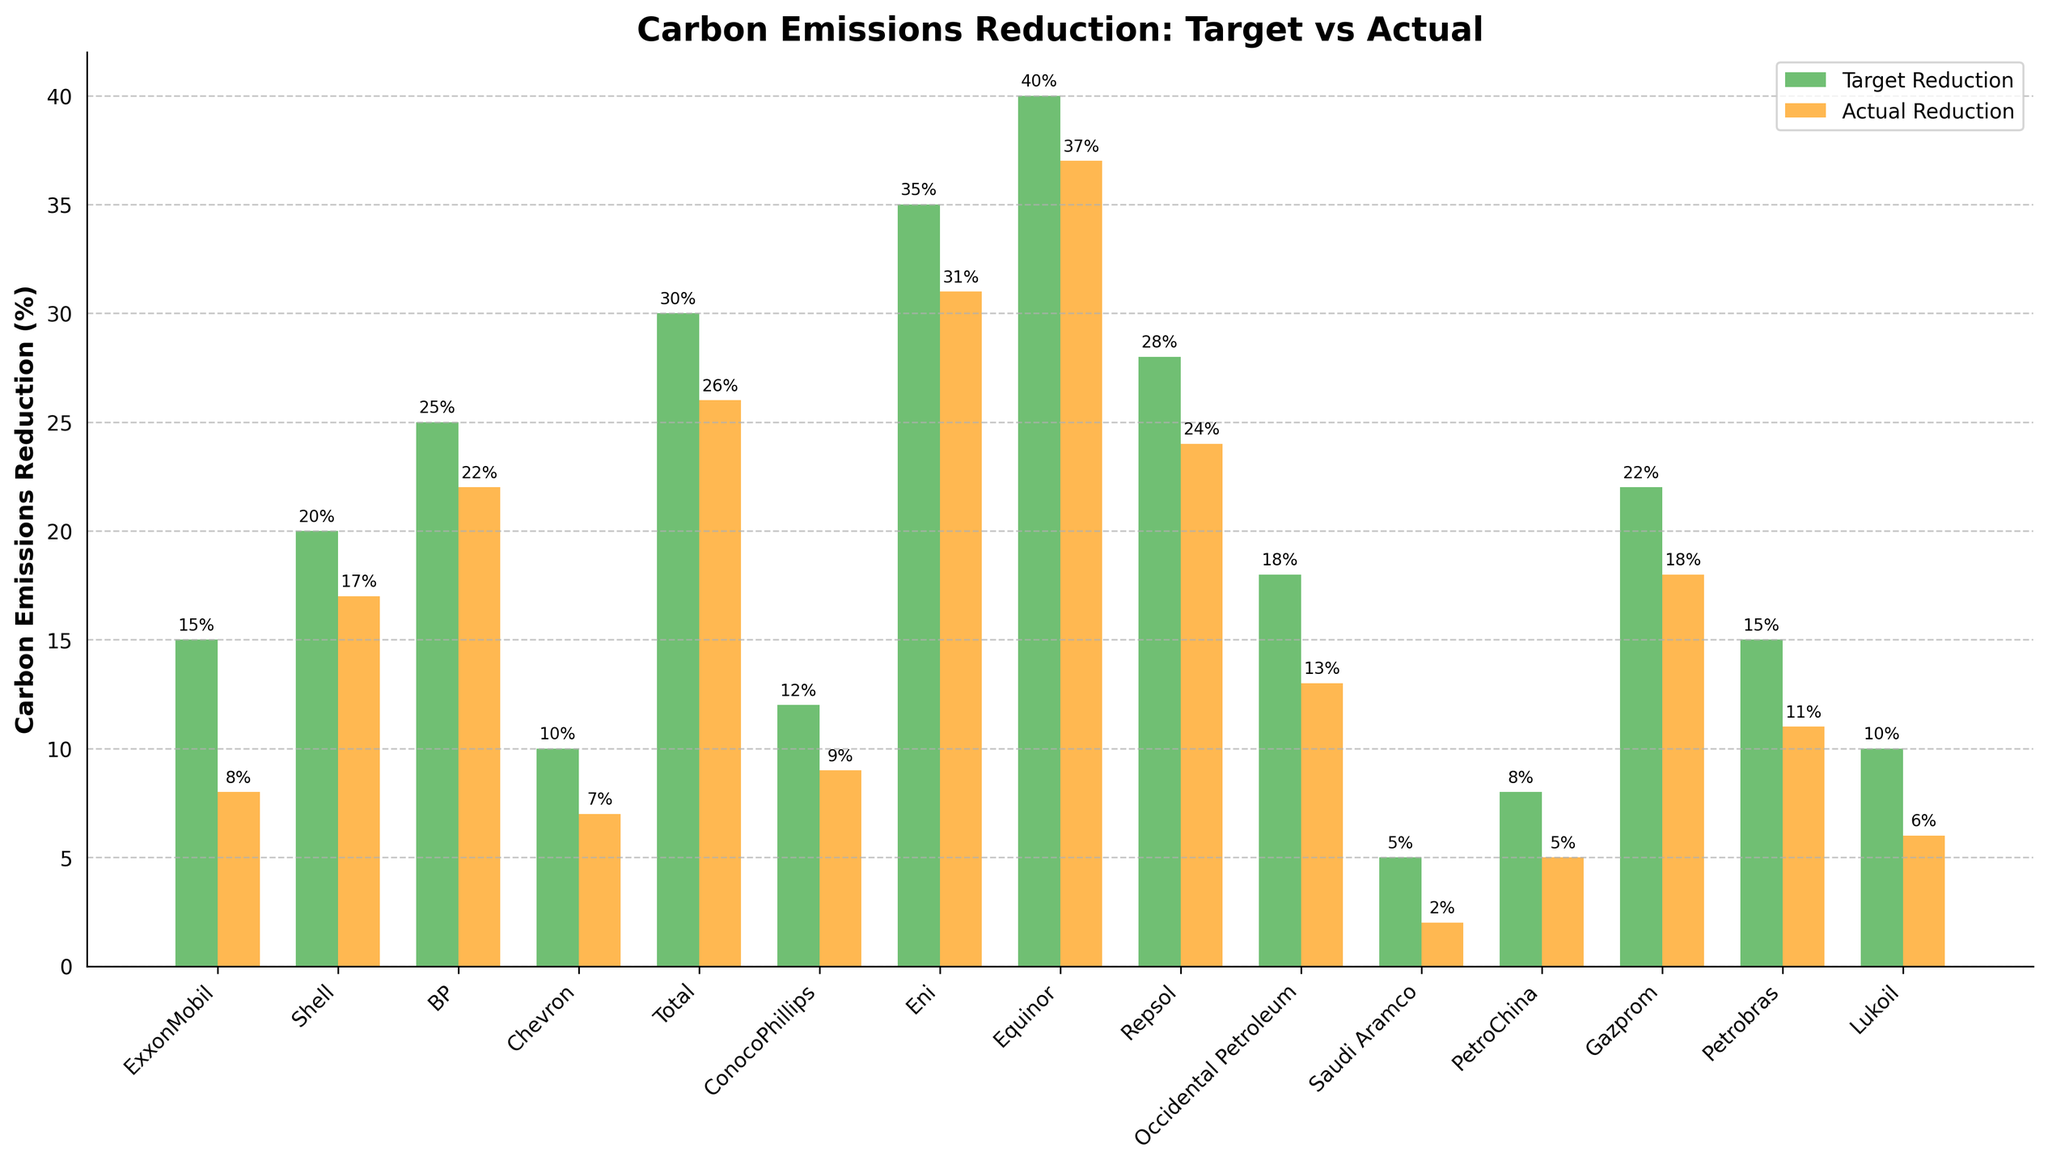Which company had the highest target reduction in carbon emissions? Identify the tallest green bar in the figure, which represents the target reduction value. Eni has the highest target reduction at 35%.
Answer: Eni Which company had the largest gap between target and actual reduction in carbon emissions? Calculate the difference between the target reduction and the actual reduction for each company and identify the largest gap. Saudi Aramco has the largest gap, with a difference of 3% (5% target - 2% actual).
Answer: Saudi Aramco Which three companies achieved the closest actual reduction to their target reduction? Assess the absolute difference between the target and the actual reductions for all companies and identify the three smallest gaps. Shell (3%), BP (3%), and Eni (4%) are the closest.
Answer: Shell, BP, and Eni How much less was Chevron’s actual reduction compared to its target reduction? Calculate the difference between Chevron’s target and actual reductions: 10% target - 7% actual = 3%.
Answer: 3% What is the average actual reduction in carbon emissions achieved by these companies? Sum all actual reductions and divide by the number of companies: (8 + 17 + 22 + 7 + 26 + 9 + 31 + 37 + 24 + 13 + 2 + 5 + 18 + 11 + 6) / 15 = 237 / 15 = 15.8%.
Answer: 15.8% Which company showed the least actual reduction in carbon emissions and by how much percentage? Identify the shortest orange bar in the chart representing the actual reduction. Saudi Aramco has the least actual reduction at 2%.
Answer: Saudi Aramco, 2% What is the combined target reduction percentage of Shell, BP, and Total? Sum the target reductions for Shell, BP, and Total: 20 + 25 + 30 = 75%.
Answer: 75% Between ExxonMobil and ConocoPhillips, which company had a higher actual reduction, and by how much? Compare the actual reduction values of both companies. ConocoPhillips has 9%, which is 1% higher than ExxonMobil’s 8%.
Answer: ConocoPhillips, 1% Which company’s actual reduction was exactly 50% lower than its target reduction? Look for the company whose actual reduction is half the target reduction. ExxonMobil’s actual reduction is 8% which is 50% of the target reduction of 15%.
Answer: ExxonMobil 